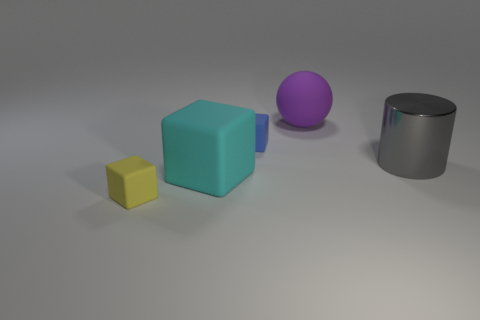Subtract all tiny cubes. How many cubes are left? 1 Add 4 large purple shiny things. How many objects exist? 9 Subtract all cyan cubes. How many cubes are left? 2 Subtract all cubes. How many objects are left? 2 Subtract all green cubes. Subtract all large gray metallic objects. How many objects are left? 4 Add 1 rubber balls. How many rubber balls are left? 2 Add 2 small rubber things. How many small rubber things exist? 4 Subtract 0 green blocks. How many objects are left? 5 Subtract 1 balls. How many balls are left? 0 Subtract all gray balls. Subtract all cyan blocks. How many balls are left? 1 